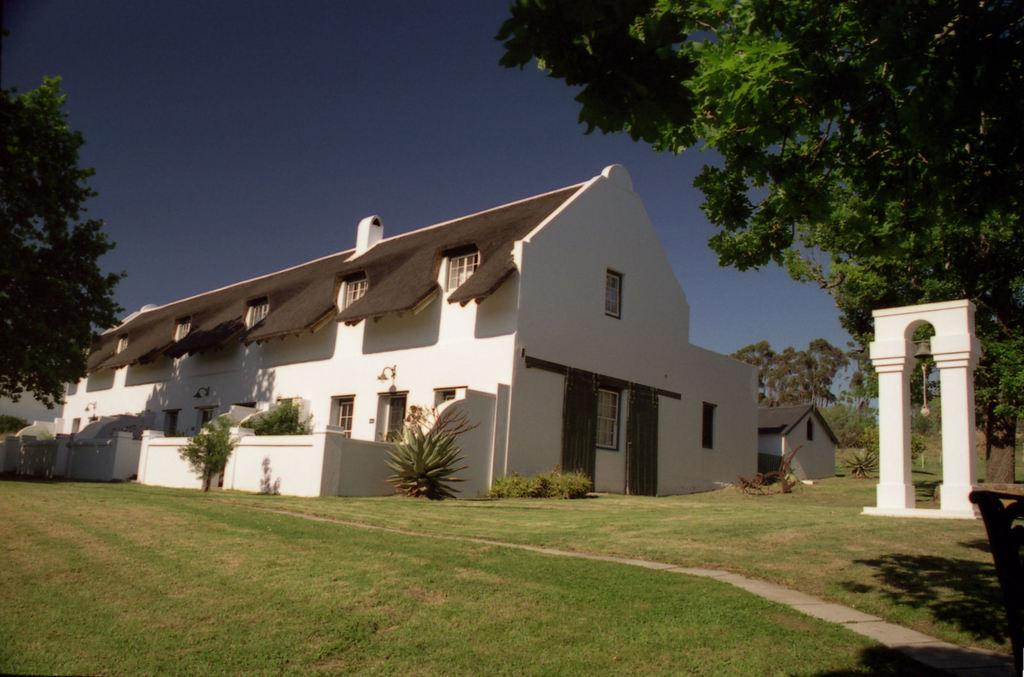What type of structure is visible in the image? There is a home in the image. Where is the home located? The home is on grassland. What can be seen on either side of the home? There are trees on either side of the home. What is attached to a wall on the right side of the home? There is a bell attached to a wall on the right side of the home. What is visible above the home? The sky is visible above the home. What type of poison is being used to protect the home from intruders in the image? There is no mention of poison or any protective measures in the image; it simply shows a home with trees and a bell on the right side. 